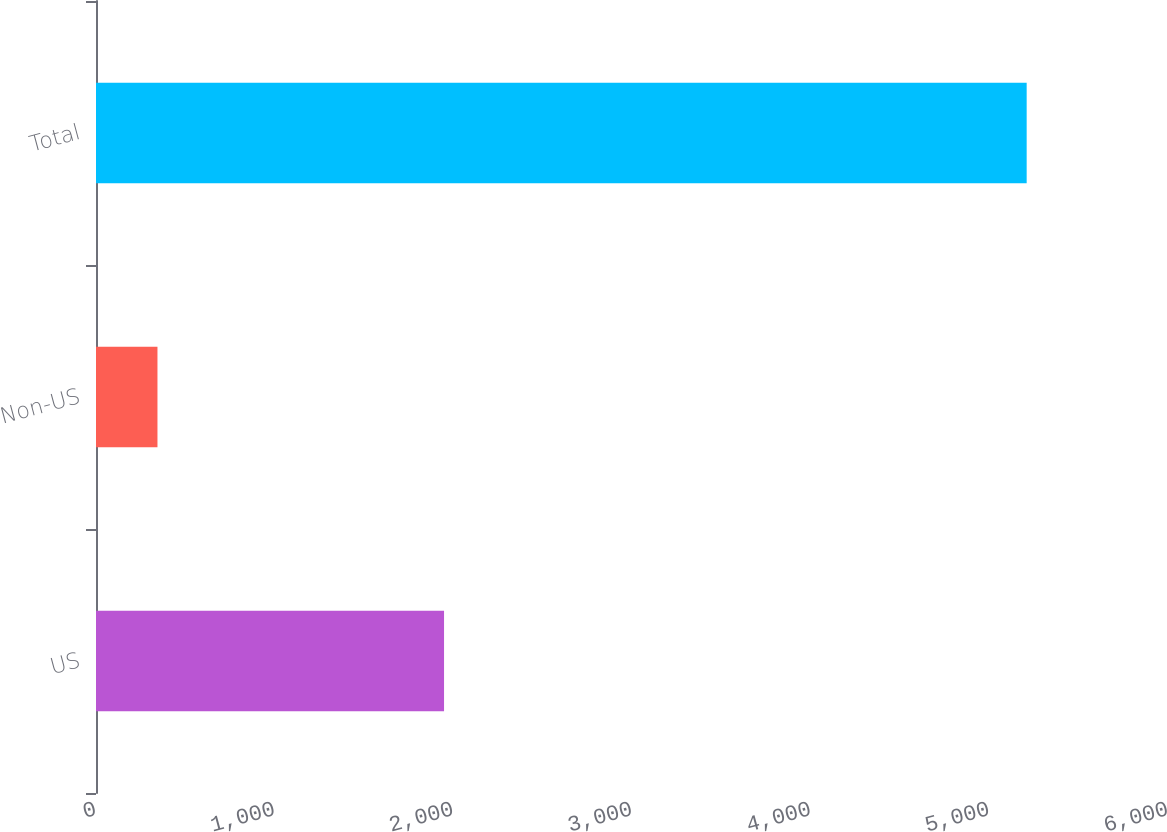Convert chart to OTSL. <chart><loc_0><loc_0><loc_500><loc_500><bar_chart><fcel>US<fcel>Non-US<fcel>Total<nl><fcel>1948<fcel>344<fcel>5209<nl></chart> 